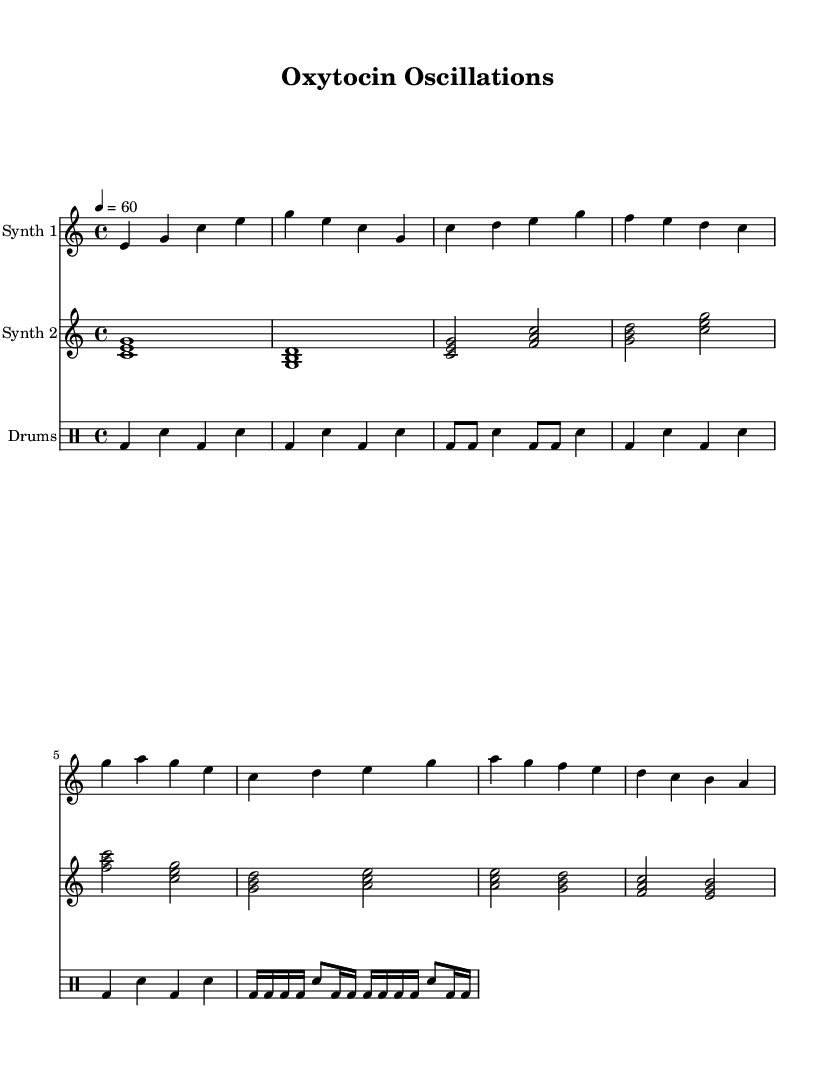What is the key signature of this music? The key signature is C major. This can be determined by looking at the absence of sharps and flats indicated in the music sheet, which typically denotes C major.
Answer: C major What is the time signature of this music? The time signature is 4/4, as indicated at the beginning of the music sheet. This means there are four beats in each measure, and the quarter note gets one beat.
Answer: 4/4 What is the tempo marking for this music? The tempo marking is 60 beats per minute. It is noted at the beginning of the piece with "4 = 60," meaning the quarter note is played at 60 beats per minute.
Answer: 60 How many sections are in the structure of the piece? There are four sections in the structure of the piece: Intro, Verse, Chorus, and Bridge. This can be identified by headings or distinct musical phrases in the score that represent these sections.
Answer: Four What are the two instruments used in this piece? The two instruments used are Synth 1 and Synth 2, which are clearly indicated as separate staves in the score, each with distinct musical lines.
Answer: Synth 1, Synth 2 Is there a drum part in this music? Yes, there is a drum part, which is written in a separate staff and uses standard drum notation. This includes different rhythms played by kick and snare drums as indicated in the score.
Answer: Yes What musical effect does the piece aim to explore? The piece aims to explore the neurochemistry of love and attachment, as described in the title "Oxytocin Oscillations." This suggests a thematic connection to emotions associated with love and bonding.
Answer: Neurochemistry of love 